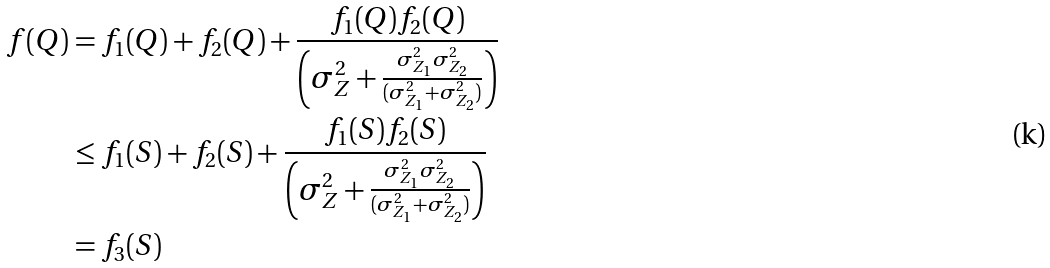Convert formula to latex. <formula><loc_0><loc_0><loc_500><loc_500>f ( Q ) & = f _ { 1 } ( Q ) + f _ { 2 } ( Q ) + \frac { f _ { 1 } ( Q ) f _ { 2 } ( Q ) } { \left ( \sigma _ { Z } ^ { 2 } + \frac { \sigma _ { Z _ { 1 } } ^ { 2 } \sigma _ { Z _ { 2 } } ^ { 2 } } { ( \sigma _ { Z _ { 1 } } ^ { 2 } + \sigma _ { Z _ { 2 } } ^ { 2 } ) } \right ) } \\ & \leq f _ { 1 } ( S ) + f _ { 2 } ( S ) + \frac { f _ { 1 } ( S ) f _ { 2 } ( S ) } { \left ( \sigma _ { Z } ^ { 2 } + \frac { \sigma _ { Z _ { 1 } } ^ { 2 } \sigma _ { Z _ { 2 } } ^ { 2 } } { ( \sigma _ { Z _ { 1 } } ^ { 2 } + \sigma _ { Z _ { 2 } } ^ { 2 } ) } \right ) } \\ & = f _ { 3 } ( S )</formula> 